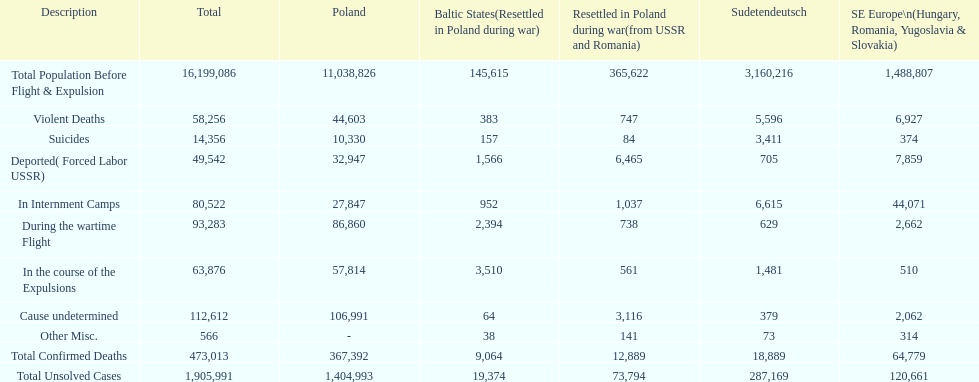Did any area experience zero violent deaths? No. 